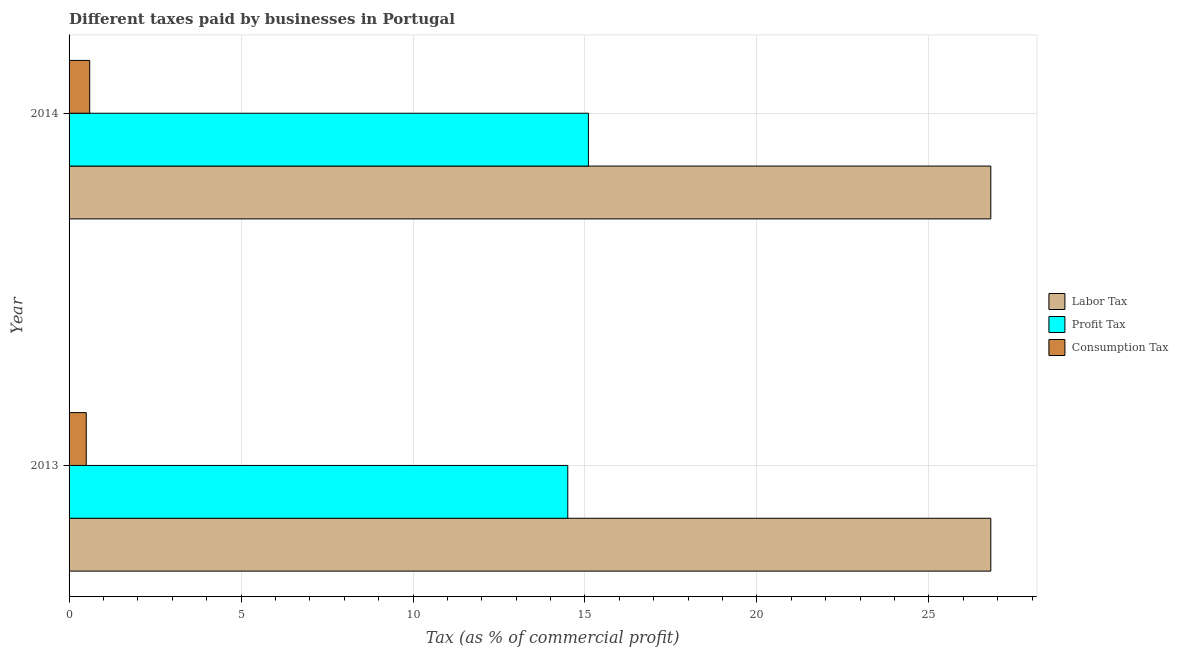How many different coloured bars are there?
Your response must be concise. 3. Are the number of bars per tick equal to the number of legend labels?
Offer a very short reply. Yes. Are the number of bars on each tick of the Y-axis equal?
Your answer should be compact. Yes. How many bars are there on the 1st tick from the top?
Your answer should be compact. 3. How many bars are there on the 2nd tick from the bottom?
Your response must be concise. 3. What is the percentage of labor tax in 2013?
Offer a very short reply. 26.8. Across all years, what is the maximum percentage of consumption tax?
Keep it short and to the point. 0.6. Across all years, what is the minimum percentage of labor tax?
Offer a very short reply. 26.8. In which year was the percentage of profit tax maximum?
Your answer should be compact. 2014. What is the total percentage of profit tax in the graph?
Make the answer very short. 29.6. What is the difference between the percentage of labor tax in 2013 and the percentage of profit tax in 2014?
Provide a succinct answer. 11.7. What is the average percentage of consumption tax per year?
Make the answer very short. 0.55. In the year 2014, what is the difference between the percentage of consumption tax and percentage of profit tax?
Provide a succinct answer. -14.5. In how many years, is the percentage of consumption tax greater than 2 %?
Offer a terse response. 0. What is the ratio of the percentage of consumption tax in 2013 to that in 2014?
Ensure brevity in your answer.  0.83. In how many years, is the percentage of labor tax greater than the average percentage of labor tax taken over all years?
Your response must be concise. 0. What does the 2nd bar from the top in 2014 represents?
Give a very brief answer. Profit Tax. What does the 2nd bar from the bottom in 2013 represents?
Provide a short and direct response. Profit Tax. How many bars are there?
Provide a short and direct response. 6. Are the values on the major ticks of X-axis written in scientific E-notation?
Ensure brevity in your answer.  No. Does the graph contain grids?
Keep it short and to the point. Yes. What is the title of the graph?
Make the answer very short. Different taxes paid by businesses in Portugal. Does "Central government" appear as one of the legend labels in the graph?
Make the answer very short. No. What is the label or title of the X-axis?
Provide a short and direct response. Tax (as % of commercial profit). What is the Tax (as % of commercial profit) in Labor Tax in 2013?
Your response must be concise. 26.8. What is the Tax (as % of commercial profit) of Labor Tax in 2014?
Your response must be concise. 26.8. What is the Tax (as % of commercial profit) in Profit Tax in 2014?
Provide a short and direct response. 15.1. What is the Tax (as % of commercial profit) of Consumption Tax in 2014?
Your answer should be compact. 0.6. Across all years, what is the maximum Tax (as % of commercial profit) in Labor Tax?
Offer a terse response. 26.8. Across all years, what is the maximum Tax (as % of commercial profit) in Profit Tax?
Offer a terse response. 15.1. Across all years, what is the maximum Tax (as % of commercial profit) of Consumption Tax?
Keep it short and to the point. 0.6. Across all years, what is the minimum Tax (as % of commercial profit) in Labor Tax?
Provide a succinct answer. 26.8. What is the total Tax (as % of commercial profit) in Labor Tax in the graph?
Your answer should be very brief. 53.6. What is the total Tax (as % of commercial profit) in Profit Tax in the graph?
Offer a terse response. 29.6. What is the difference between the Tax (as % of commercial profit) in Profit Tax in 2013 and that in 2014?
Your answer should be compact. -0.6. What is the difference between the Tax (as % of commercial profit) in Labor Tax in 2013 and the Tax (as % of commercial profit) in Consumption Tax in 2014?
Your response must be concise. 26.2. What is the difference between the Tax (as % of commercial profit) in Profit Tax in 2013 and the Tax (as % of commercial profit) in Consumption Tax in 2014?
Offer a very short reply. 13.9. What is the average Tax (as % of commercial profit) of Labor Tax per year?
Offer a very short reply. 26.8. What is the average Tax (as % of commercial profit) in Profit Tax per year?
Keep it short and to the point. 14.8. What is the average Tax (as % of commercial profit) in Consumption Tax per year?
Ensure brevity in your answer.  0.55. In the year 2013, what is the difference between the Tax (as % of commercial profit) in Labor Tax and Tax (as % of commercial profit) in Profit Tax?
Your answer should be very brief. 12.3. In the year 2013, what is the difference between the Tax (as % of commercial profit) of Labor Tax and Tax (as % of commercial profit) of Consumption Tax?
Offer a terse response. 26.3. In the year 2013, what is the difference between the Tax (as % of commercial profit) in Profit Tax and Tax (as % of commercial profit) in Consumption Tax?
Give a very brief answer. 14. In the year 2014, what is the difference between the Tax (as % of commercial profit) of Labor Tax and Tax (as % of commercial profit) of Profit Tax?
Your response must be concise. 11.7. In the year 2014, what is the difference between the Tax (as % of commercial profit) in Labor Tax and Tax (as % of commercial profit) in Consumption Tax?
Give a very brief answer. 26.2. In the year 2014, what is the difference between the Tax (as % of commercial profit) of Profit Tax and Tax (as % of commercial profit) of Consumption Tax?
Your answer should be very brief. 14.5. What is the ratio of the Tax (as % of commercial profit) in Labor Tax in 2013 to that in 2014?
Make the answer very short. 1. What is the ratio of the Tax (as % of commercial profit) in Profit Tax in 2013 to that in 2014?
Keep it short and to the point. 0.96. What is the difference between the highest and the second highest Tax (as % of commercial profit) in Labor Tax?
Provide a succinct answer. 0. What is the difference between the highest and the second highest Tax (as % of commercial profit) of Profit Tax?
Make the answer very short. 0.6. What is the difference between the highest and the second highest Tax (as % of commercial profit) of Consumption Tax?
Keep it short and to the point. 0.1. What is the difference between the highest and the lowest Tax (as % of commercial profit) in Consumption Tax?
Provide a short and direct response. 0.1. 